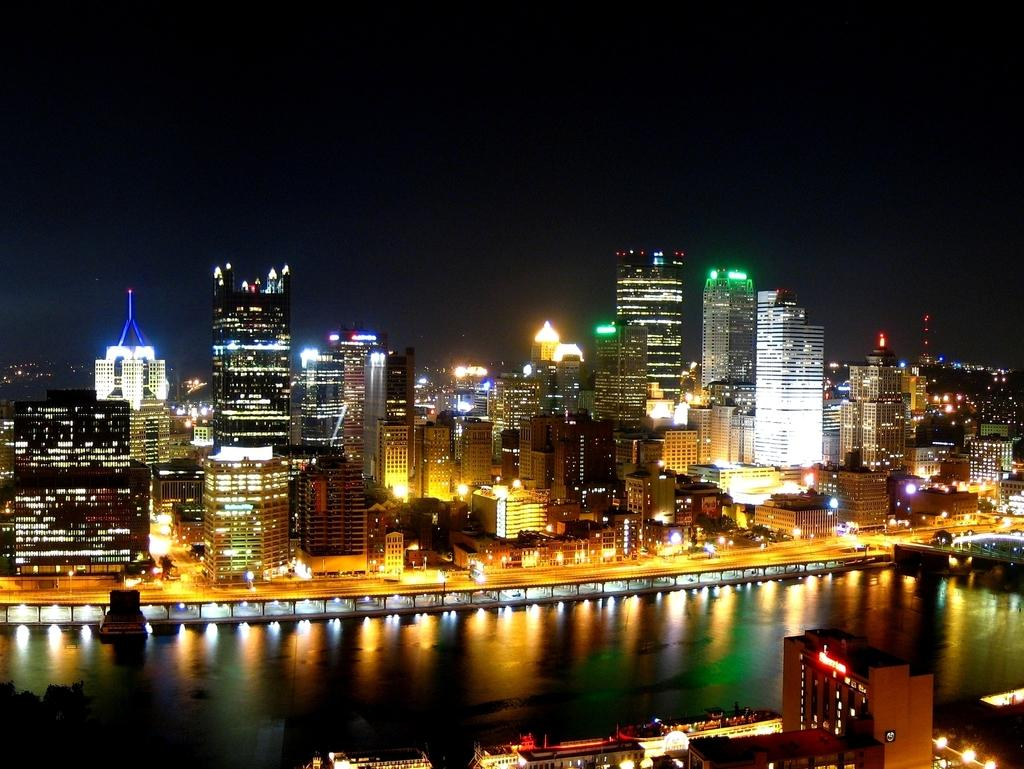What type of structures are present in the image? There are buildings with lights in the image. What natural element is visible in the image? There is water visible in the image. What is the time of day in the image? It is nighttime in the image, as the sky is visible at the top and it is dark. Where is the goat located in the image? There is no goat present in the image. What type of development is taking place in the middle of the image? There is no development or construction activity visible in the image; it primarily features buildings with lights and water. 